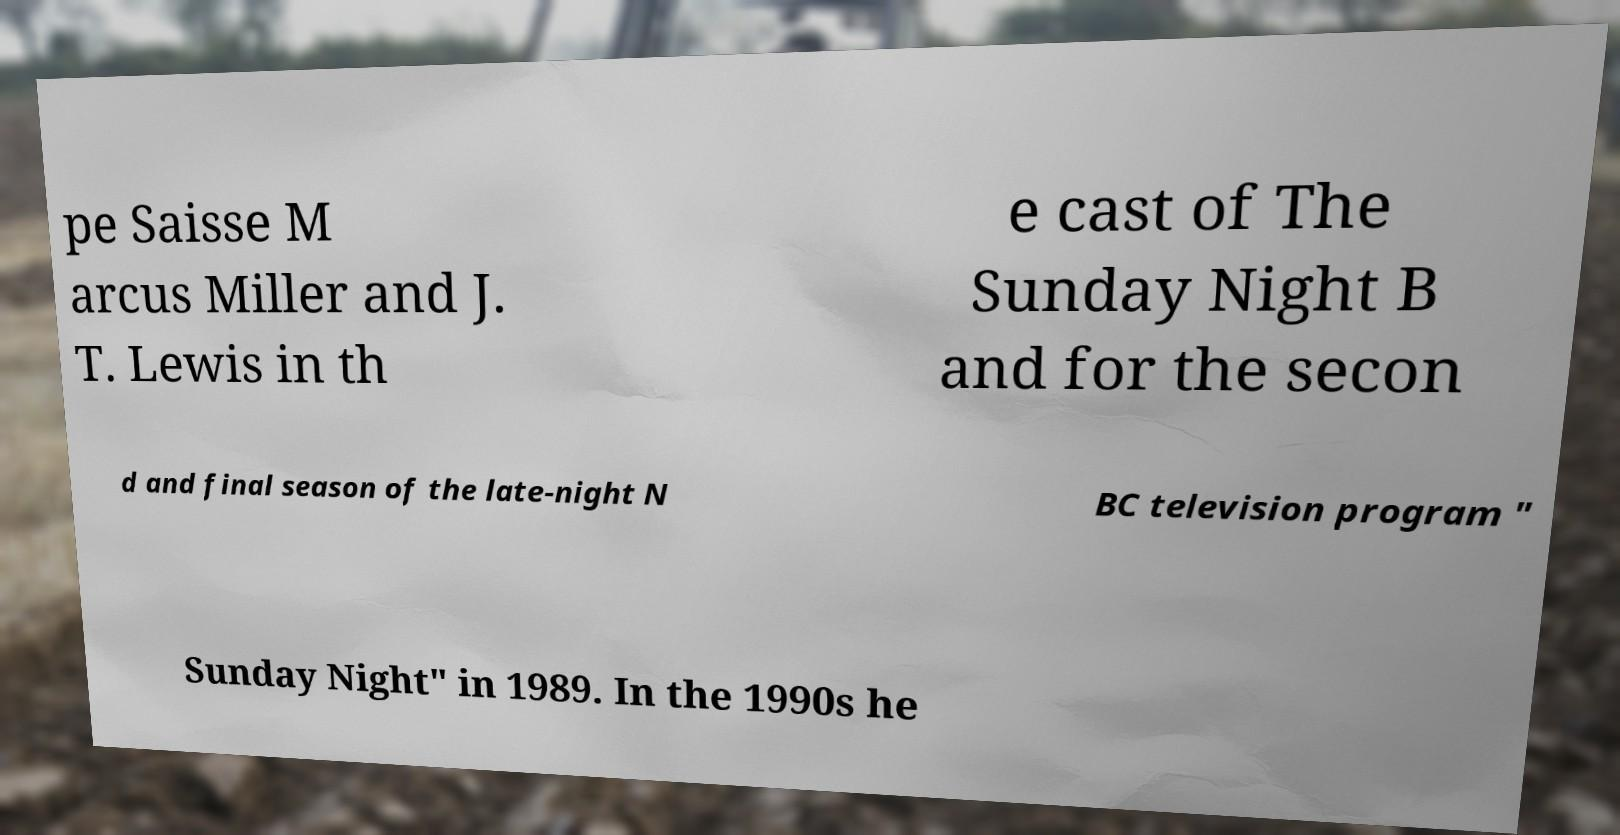What messages or text are displayed in this image? I need them in a readable, typed format. pe Saisse M arcus Miller and J. T. Lewis in th e cast of The Sunday Night B and for the secon d and final season of the late-night N BC television program " Sunday Night" in 1989. In the 1990s he 